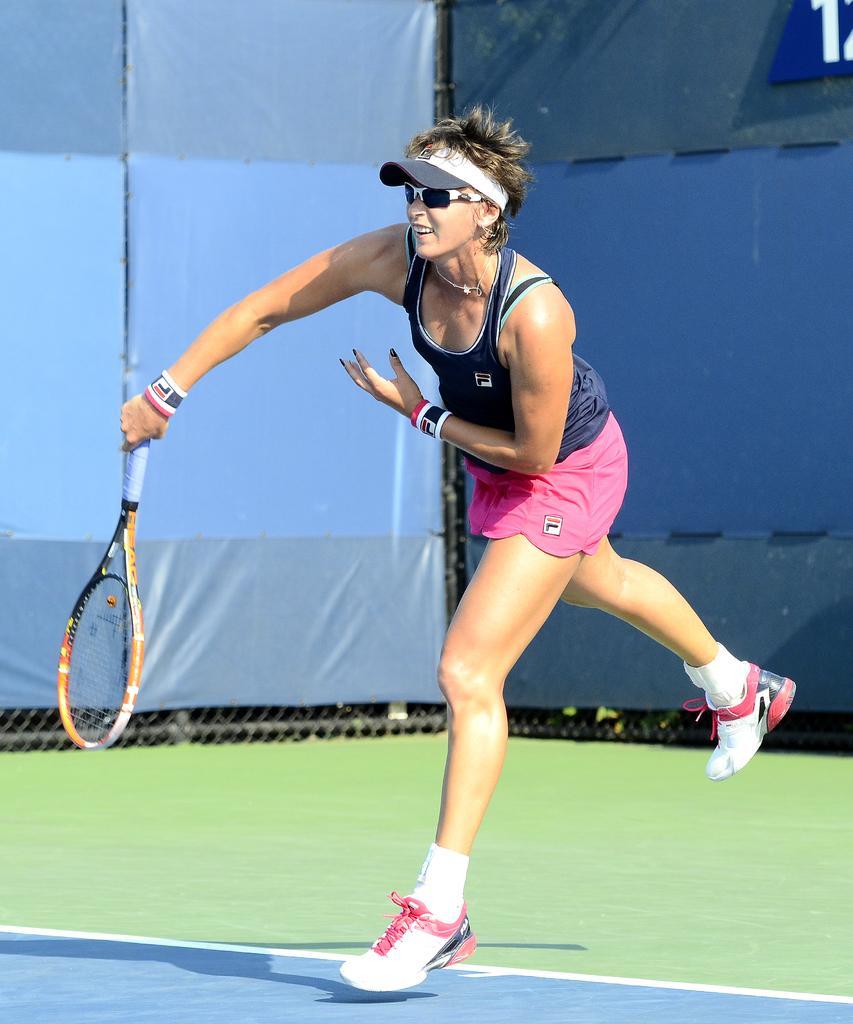Could you give a brief overview of what you see in this image? In this image we can see a woman standing on the ground. On the backside we can see the fence. 